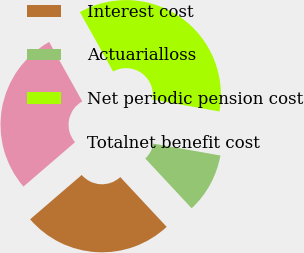<chart> <loc_0><loc_0><loc_500><loc_500><pie_chart><fcel>Interest cost<fcel>Actuarialloss<fcel>Net periodic pension cost<fcel>Totalnet benefit cost<nl><fcel>25.64%<fcel>10.26%<fcel>35.9%<fcel>28.21%<nl></chart> 